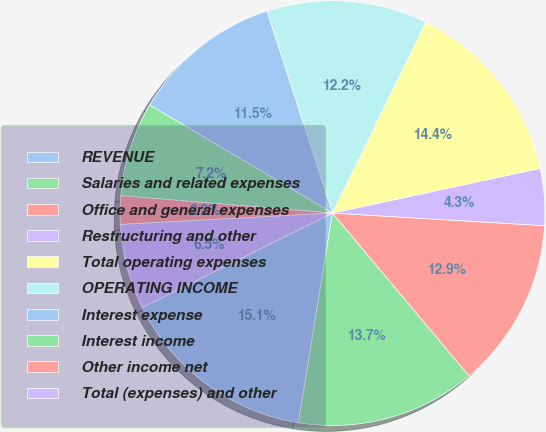Convert chart. <chart><loc_0><loc_0><loc_500><loc_500><pie_chart><fcel>REVENUE<fcel>Salaries and related expenses<fcel>Office and general expenses<fcel>Restructuring and other<fcel>Total operating expenses<fcel>OPERATING INCOME<fcel>Interest expense<fcel>Interest income<fcel>Other income net<fcel>Total (expenses) and other<nl><fcel>15.11%<fcel>13.67%<fcel>12.95%<fcel>4.32%<fcel>14.39%<fcel>12.23%<fcel>11.51%<fcel>7.19%<fcel>2.16%<fcel>6.47%<nl></chart> 